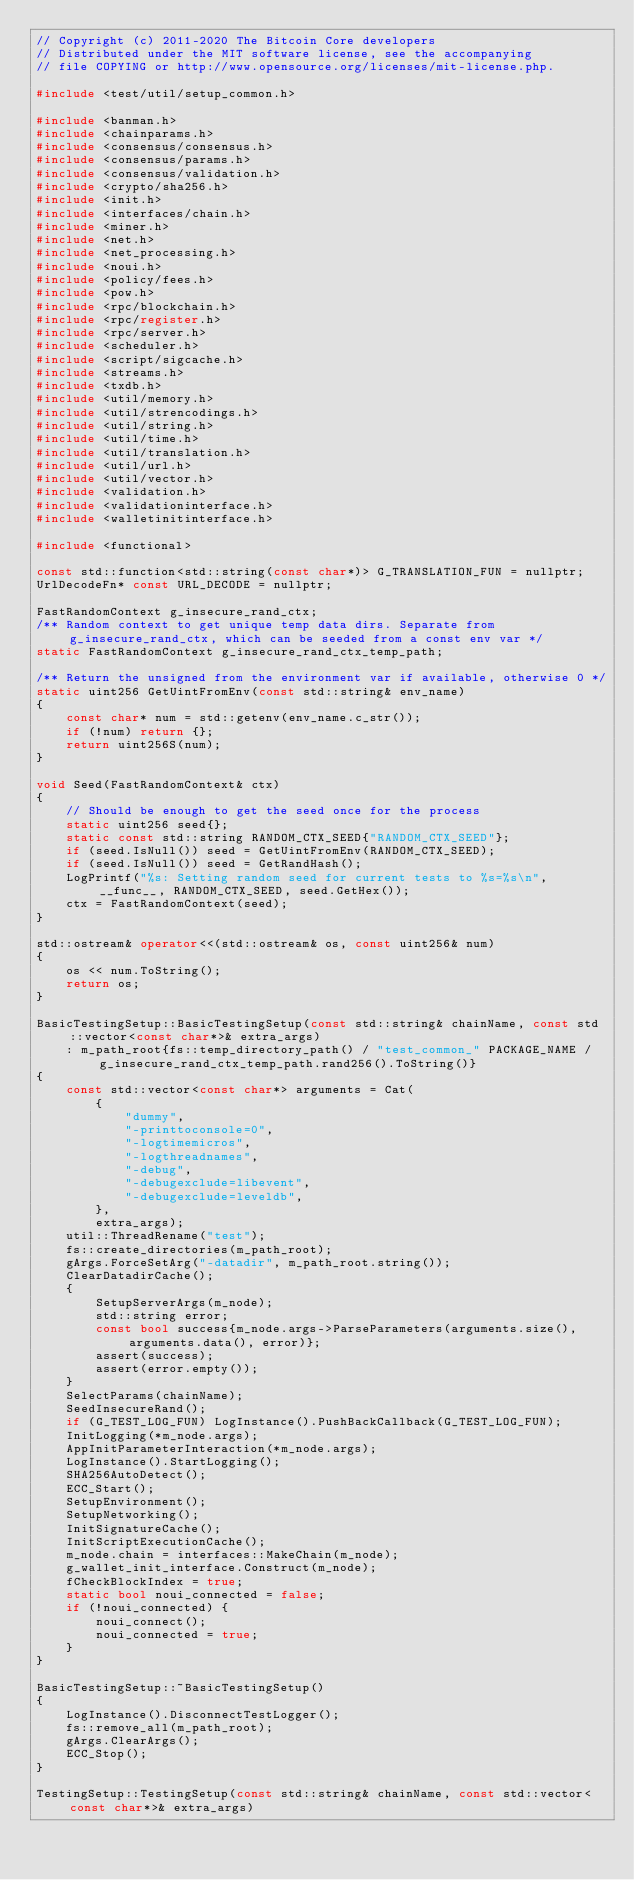<code> <loc_0><loc_0><loc_500><loc_500><_C++_>// Copyright (c) 2011-2020 The Bitcoin Core developers
// Distributed under the MIT software license, see the accompanying
// file COPYING or http://www.opensource.org/licenses/mit-license.php.

#include <test/util/setup_common.h>

#include <banman.h>
#include <chainparams.h>
#include <consensus/consensus.h>
#include <consensus/params.h>
#include <consensus/validation.h>
#include <crypto/sha256.h>
#include <init.h>
#include <interfaces/chain.h>
#include <miner.h>
#include <net.h>
#include <net_processing.h>
#include <noui.h>
#include <policy/fees.h>
#include <pow.h>
#include <rpc/blockchain.h>
#include <rpc/register.h>
#include <rpc/server.h>
#include <scheduler.h>
#include <script/sigcache.h>
#include <streams.h>
#include <txdb.h>
#include <util/memory.h>
#include <util/strencodings.h>
#include <util/string.h>
#include <util/time.h>
#include <util/translation.h>
#include <util/url.h>
#include <util/vector.h>
#include <validation.h>
#include <validationinterface.h>
#include <walletinitinterface.h>

#include <functional>

const std::function<std::string(const char*)> G_TRANSLATION_FUN = nullptr;
UrlDecodeFn* const URL_DECODE = nullptr;

FastRandomContext g_insecure_rand_ctx;
/** Random context to get unique temp data dirs. Separate from g_insecure_rand_ctx, which can be seeded from a const env var */
static FastRandomContext g_insecure_rand_ctx_temp_path;

/** Return the unsigned from the environment var if available, otherwise 0 */
static uint256 GetUintFromEnv(const std::string& env_name)
{
    const char* num = std::getenv(env_name.c_str());
    if (!num) return {};
    return uint256S(num);
}

void Seed(FastRandomContext& ctx)
{
    // Should be enough to get the seed once for the process
    static uint256 seed{};
    static const std::string RANDOM_CTX_SEED{"RANDOM_CTX_SEED"};
    if (seed.IsNull()) seed = GetUintFromEnv(RANDOM_CTX_SEED);
    if (seed.IsNull()) seed = GetRandHash();
    LogPrintf("%s: Setting random seed for current tests to %s=%s\n", __func__, RANDOM_CTX_SEED, seed.GetHex());
    ctx = FastRandomContext(seed);
}

std::ostream& operator<<(std::ostream& os, const uint256& num)
{
    os << num.ToString();
    return os;
}

BasicTestingSetup::BasicTestingSetup(const std::string& chainName, const std::vector<const char*>& extra_args)
    : m_path_root{fs::temp_directory_path() / "test_common_" PACKAGE_NAME / g_insecure_rand_ctx_temp_path.rand256().ToString()}
{
    const std::vector<const char*> arguments = Cat(
        {
            "dummy",
            "-printtoconsole=0",
            "-logtimemicros",
            "-logthreadnames",
            "-debug",
            "-debugexclude=libevent",
            "-debugexclude=leveldb",
        },
        extra_args);
    util::ThreadRename("test");
    fs::create_directories(m_path_root);
    gArgs.ForceSetArg("-datadir", m_path_root.string());
    ClearDatadirCache();
    {
        SetupServerArgs(m_node);
        std::string error;
        const bool success{m_node.args->ParseParameters(arguments.size(), arguments.data(), error)};
        assert(success);
        assert(error.empty());
    }
    SelectParams(chainName);
    SeedInsecureRand();
    if (G_TEST_LOG_FUN) LogInstance().PushBackCallback(G_TEST_LOG_FUN);
    InitLogging(*m_node.args);
    AppInitParameterInteraction(*m_node.args);
    LogInstance().StartLogging();
    SHA256AutoDetect();
    ECC_Start();
    SetupEnvironment();
    SetupNetworking();
    InitSignatureCache();
    InitScriptExecutionCache();
    m_node.chain = interfaces::MakeChain(m_node);
    g_wallet_init_interface.Construct(m_node);
    fCheckBlockIndex = true;
    static bool noui_connected = false;
    if (!noui_connected) {
        noui_connect();
        noui_connected = true;
    }
}

BasicTestingSetup::~BasicTestingSetup()
{
    LogInstance().DisconnectTestLogger();
    fs::remove_all(m_path_root);
    gArgs.ClearArgs();
    ECC_Stop();
}

TestingSetup::TestingSetup(const std::string& chainName, const std::vector<const char*>& extra_args)</code> 